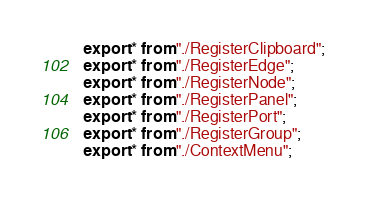Convert code to text. <code><loc_0><loc_0><loc_500><loc_500><_TypeScript_>export * from "./RegisterClipboard";
export * from "./RegisterEdge";
export * from "./RegisterNode";
export * from "./RegisterPanel";
export * from "./RegisterPort";
export * from "./RegisterGroup";
export * from "./ContextMenu";
</code> 